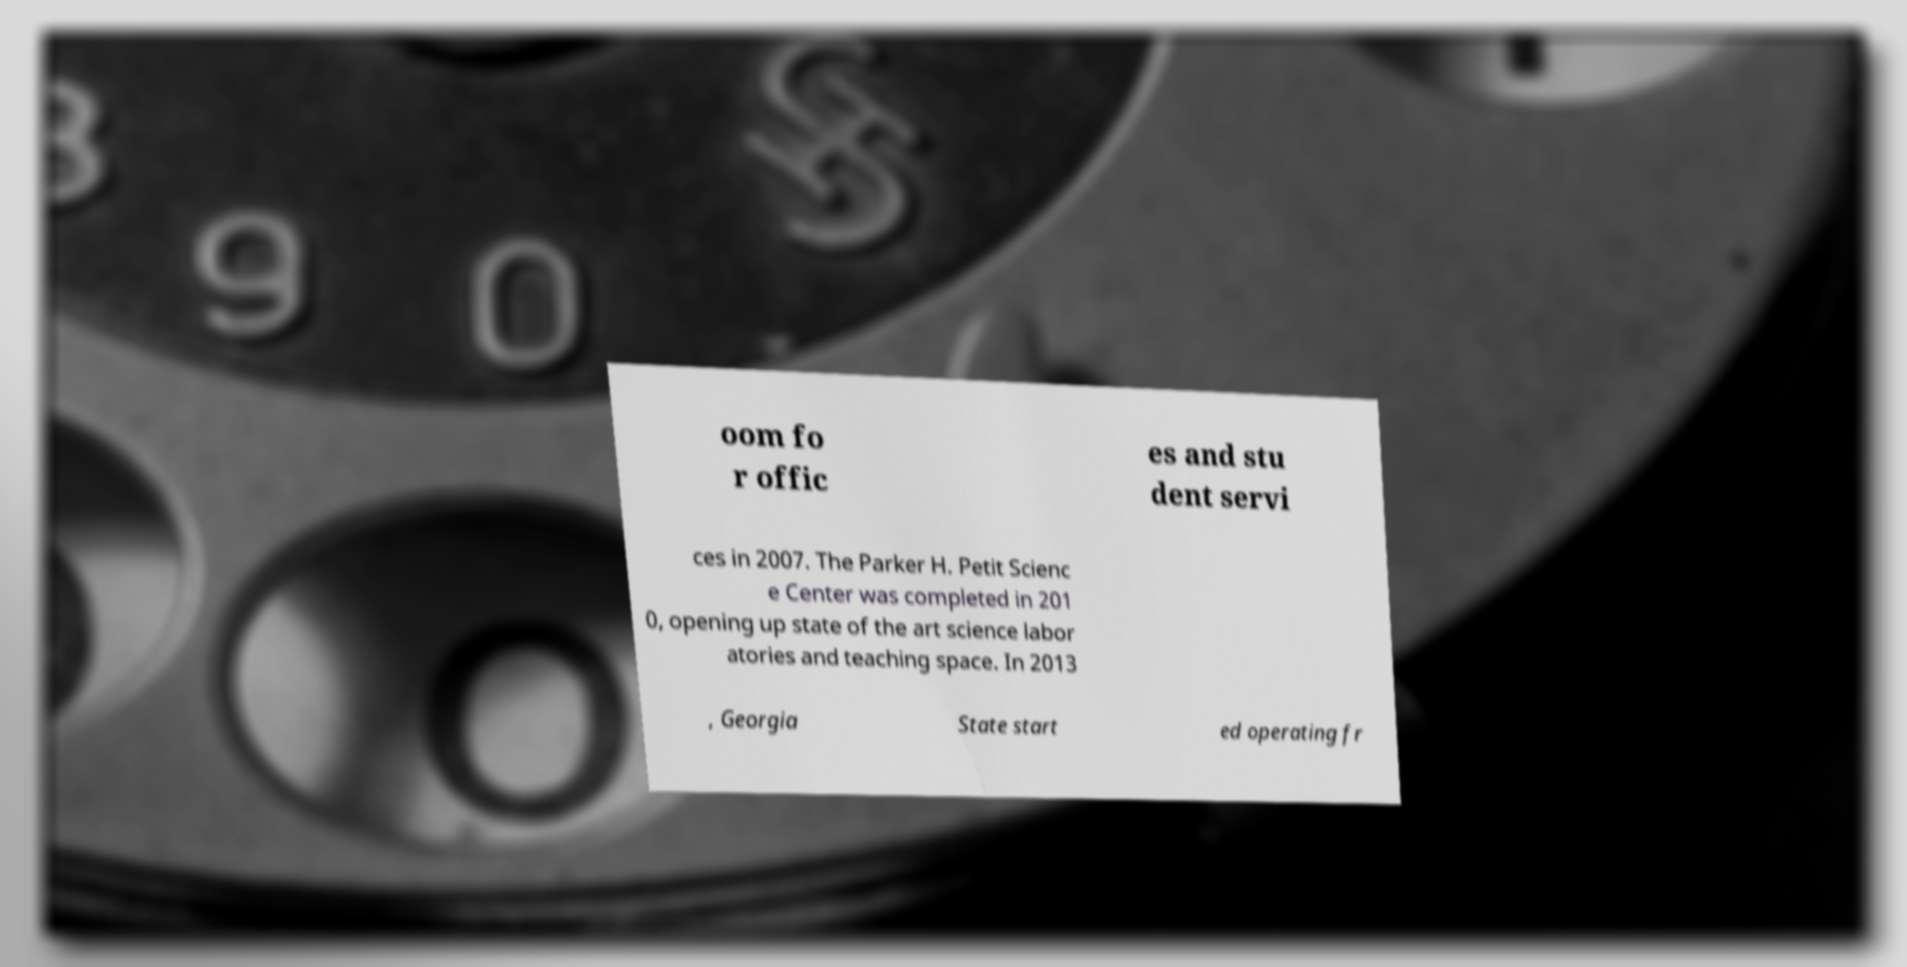For documentation purposes, I need the text within this image transcribed. Could you provide that? oom fo r offic es and stu dent servi ces in 2007. The Parker H. Petit Scienc e Center was completed in 201 0, opening up state of the art science labor atories and teaching space. In 2013 , Georgia State start ed operating fr 